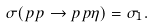<formula> <loc_0><loc_0><loc_500><loc_500>\sigma ( p p \to p p \eta ) = \sigma _ { 1 } .</formula> 